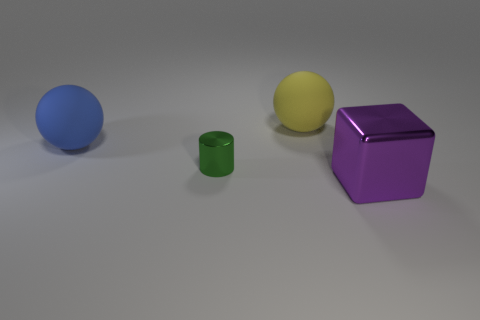Subtract all cyan spheres. Subtract all yellow blocks. How many spheres are left? 2 Subtract all blue blocks. How many gray cylinders are left? 0 Add 1 big purples. How many large objects exist? 0 Subtract all tiny purple matte spheres. Subtract all green shiny cylinders. How many objects are left? 3 Add 3 large yellow things. How many large yellow things are left? 4 Add 1 tiny cubes. How many tiny cubes exist? 1 Add 3 big gray rubber objects. How many objects exist? 7 Subtract all blue balls. How many balls are left? 1 Subtract 0 green cubes. How many objects are left? 4 Subtract all cylinders. How many objects are left? 3 